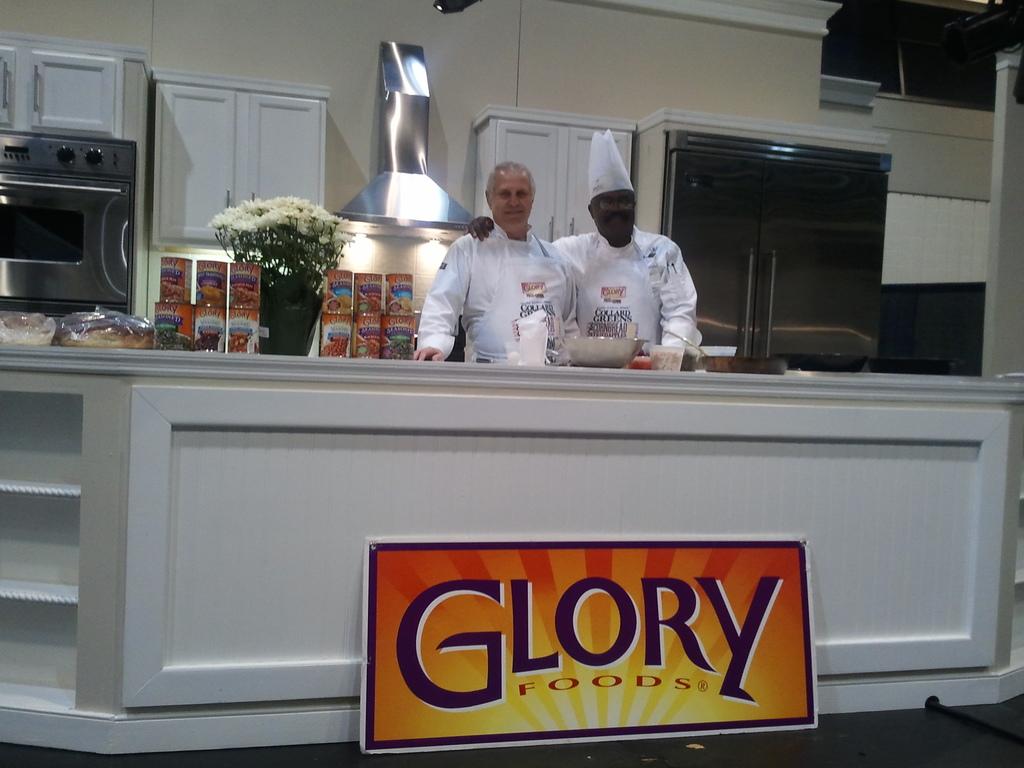What is the food brand called?
Your answer should be very brief. Glory. 